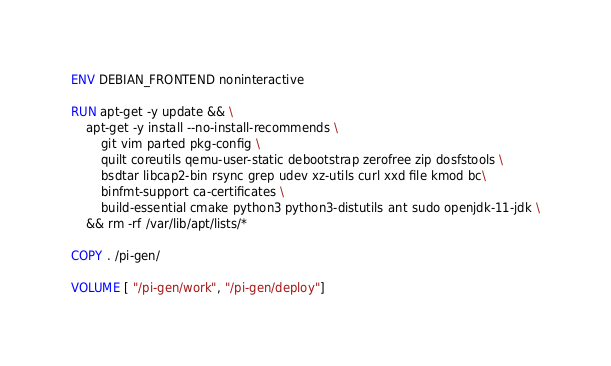Convert code to text. <code><loc_0><loc_0><loc_500><loc_500><_Dockerfile_>
ENV DEBIAN_FRONTEND noninteractive

RUN apt-get -y update && \
    apt-get -y install --no-install-recommends \
        git vim parted pkg-config \
        quilt coreutils qemu-user-static debootstrap zerofree zip dosfstools \
        bsdtar libcap2-bin rsync grep udev xz-utils curl xxd file kmod bc\
        binfmt-support ca-certificates \
        build-essential cmake python3 python3-distutils ant sudo openjdk-11-jdk \
    && rm -rf /var/lib/apt/lists/*

COPY . /pi-gen/

VOLUME [ "/pi-gen/work", "/pi-gen/deploy"]
</code> 